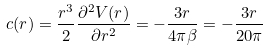<formula> <loc_0><loc_0><loc_500><loc_500>c ( r ) = \frac { r ^ { 3 } } { 2 } \frac { \partial ^ { 2 } V ( r ) } { \partial r ^ { 2 } } = - \frac { 3 r } { 4 \pi \beta } = - \frac { 3 r } { 2 0 \pi }</formula> 